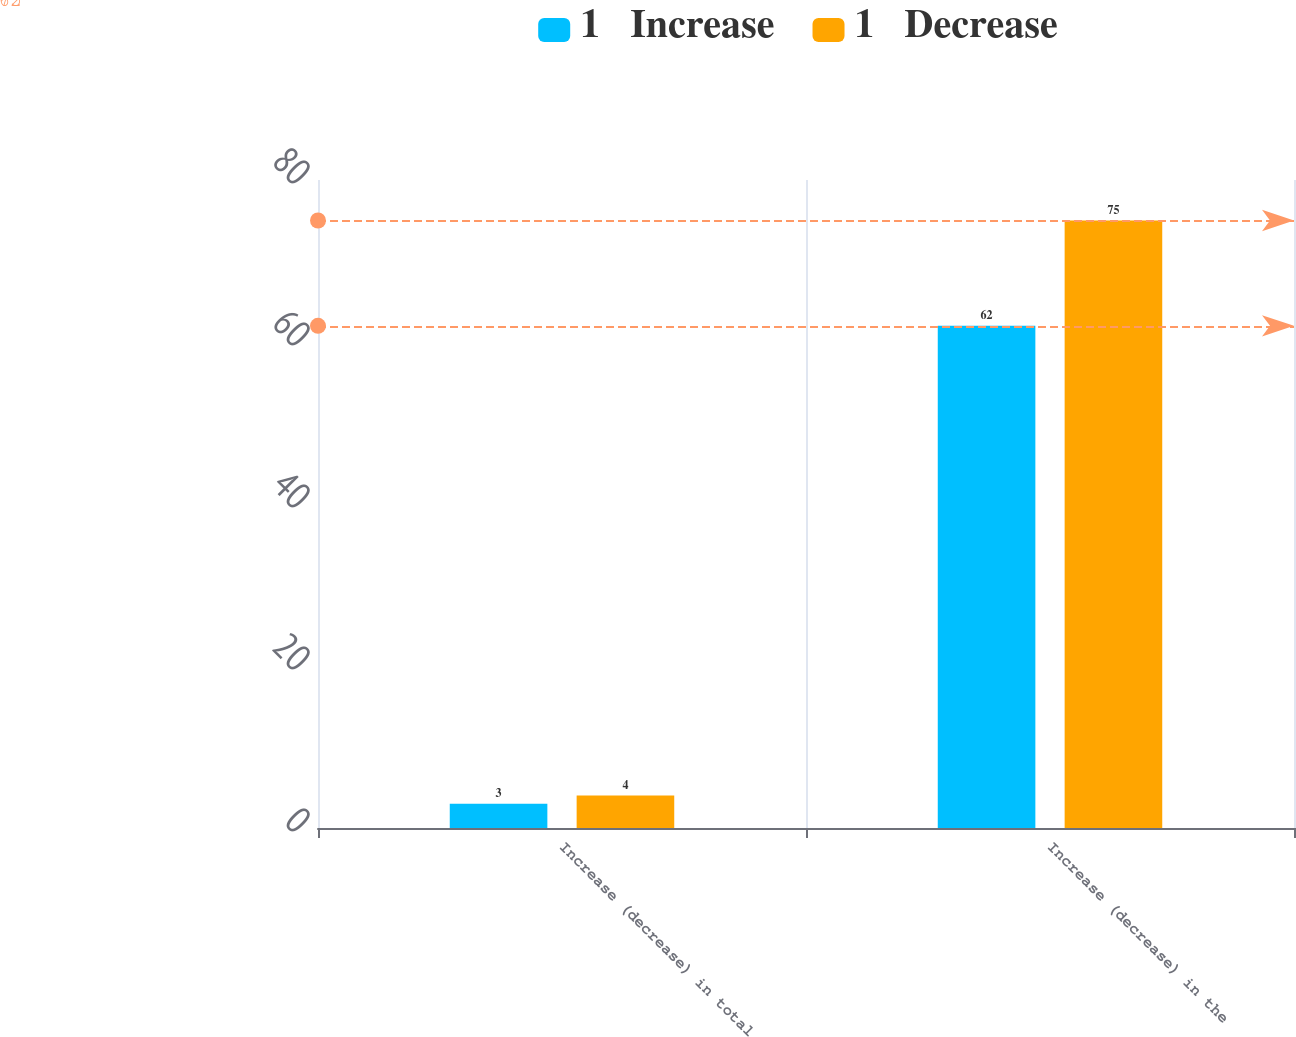<chart> <loc_0><loc_0><loc_500><loc_500><stacked_bar_chart><ecel><fcel>Increase (decrease) in total<fcel>Increase (decrease) in the<nl><fcel>1   Increase<fcel>3<fcel>62<nl><fcel>1   Decrease<fcel>4<fcel>75<nl></chart> 